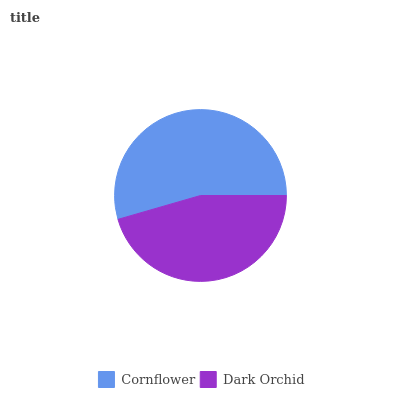Is Dark Orchid the minimum?
Answer yes or no. Yes. Is Cornflower the maximum?
Answer yes or no. Yes. Is Dark Orchid the maximum?
Answer yes or no. No. Is Cornflower greater than Dark Orchid?
Answer yes or no. Yes. Is Dark Orchid less than Cornflower?
Answer yes or no. Yes. Is Dark Orchid greater than Cornflower?
Answer yes or no. No. Is Cornflower less than Dark Orchid?
Answer yes or no. No. Is Cornflower the high median?
Answer yes or no. Yes. Is Dark Orchid the low median?
Answer yes or no. Yes. Is Dark Orchid the high median?
Answer yes or no. No. Is Cornflower the low median?
Answer yes or no. No. 